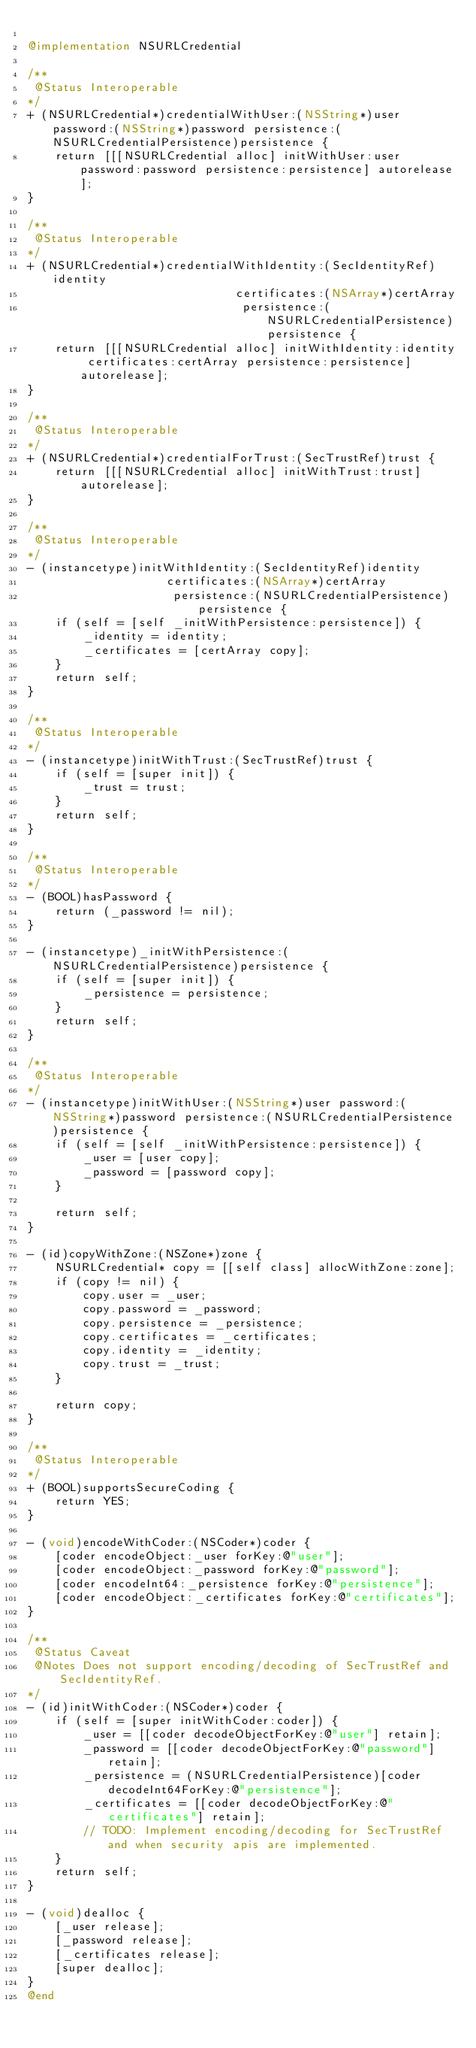Convert code to text. <code><loc_0><loc_0><loc_500><loc_500><_ObjectiveC_>
@implementation NSURLCredential

/**
 @Status Interoperable
*/
+ (NSURLCredential*)credentialWithUser:(NSString*)user password:(NSString*)password persistence:(NSURLCredentialPersistence)persistence {
    return [[[NSURLCredential alloc] initWithUser:user password:password persistence:persistence] autorelease];
}

/**
 @Status Interoperable
*/
+ (NSURLCredential*)credentialWithIdentity:(SecIdentityRef)identity
                              certificates:(NSArray*)certArray
                               persistence:(NSURLCredentialPersistence)persistence {
    return [[[NSURLCredential alloc] initWithIdentity:identity certificates:certArray persistence:persistence] autorelease];
}

/**
 @Status Interoperable
*/
+ (NSURLCredential*)credentialForTrust:(SecTrustRef)trust {
    return [[[NSURLCredential alloc] initWithTrust:trust] autorelease];
}

/**
 @Status Interoperable
*/
- (instancetype)initWithIdentity:(SecIdentityRef)identity
                    certificates:(NSArray*)certArray
                     persistence:(NSURLCredentialPersistence)persistence {
    if (self = [self _initWithPersistence:persistence]) {
        _identity = identity;
        _certificates = [certArray copy];
    }
    return self;
}

/**
 @Status Interoperable
*/
- (instancetype)initWithTrust:(SecTrustRef)trust {
    if (self = [super init]) {
        _trust = trust;
    }
    return self;
}

/**
 @Status Interoperable
*/
- (BOOL)hasPassword {
    return (_password != nil);
}

- (instancetype)_initWithPersistence:(NSURLCredentialPersistence)persistence {
    if (self = [super init]) {
        _persistence = persistence;
    }
    return self;
}

/**
 @Status Interoperable
*/
- (instancetype)initWithUser:(NSString*)user password:(NSString*)password persistence:(NSURLCredentialPersistence)persistence {
    if (self = [self _initWithPersistence:persistence]) {
        _user = [user copy];
        _password = [password copy];
    }

    return self;
}

- (id)copyWithZone:(NSZone*)zone {
    NSURLCredential* copy = [[self class] allocWithZone:zone];
    if (copy != nil) {
        copy.user = _user;
        copy.password = _password;
        copy.persistence = _persistence;
        copy.certificates = _certificates;
        copy.identity = _identity;
        copy.trust = _trust;
    }

    return copy;
}

/**
 @Status Interoperable
*/
+ (BOOL)supportsSecureCoding {
    return YES;
}

- (void)encodeWithCoder:(NSCoder*)coder {
    [coder encodeObject:_user forKey:@"user"];
    [coder encodeObject:_password forKey:@"password"];
    [coder encodeInt64:_persistence forKey:@"persistence"];
    [coder encodeObject:_certificates forKey:@"certificates"];
}

/**
 @Status Caveat
 @Notes Does not support encoding/decoding of SecTrustRef and SecIdentityRef.
*/
- (id)initWithCoder:(NSCoder*)coder {
    if (self = [super initWithCoder:coder]) {
        _user = [[coder decodeObjectForKey:@"user"] retain];
        _password = [[coder decodeObjectForKey:@"password"] retain];
        _persistence = (NSURLCredentialPersistence)[coder decodeInt64ForKey:@"persistence"];
        _certificates = [[coder decodeObjectForKey:@"certificates"] retain];
        // TODO: Implement encoding/decoding for SecTrustRef and when security apis are implemented.
    }
    return self;
}

- (void)dealloc {
    [_user release];
    [_password release];
    [_certificates release];
    [super dealloc];
}
@end</code> 